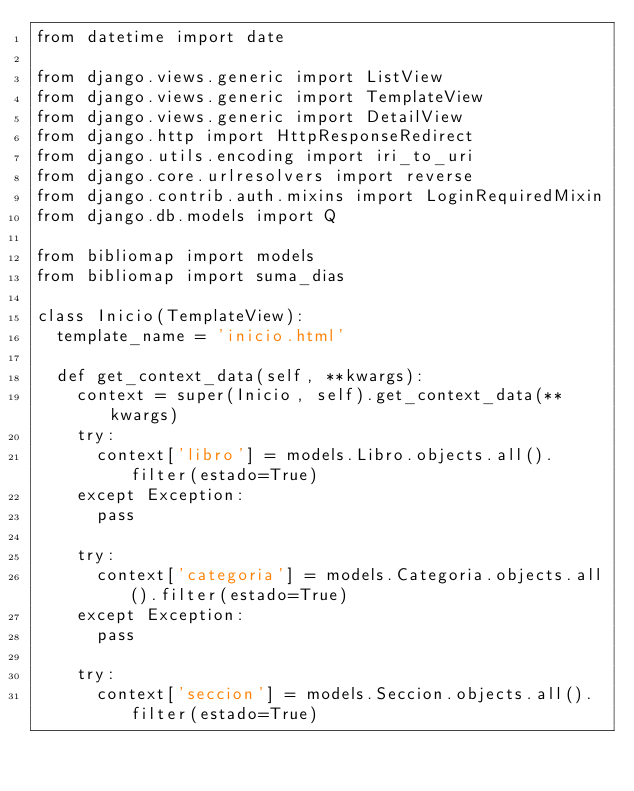Convert code to text. <code><loc_0><loc_0><loc_500><loc_500><_Python_>from datetime import date

from django.views.generic import ListView
from django.views.generic import TemplateView
from django.views.generic import DetailView
from django.http import HttpResponseRedirect
from django.utils.encoding import iri_to_uri
from django.core.urlresolvers import reverse
from django.contrib.auth.mixins import LoginRequiredMixin
from django.db.models import Q

from bibliomap import models
from bibliomap import suma_dias

class Inicio(TemplateView):
	template_name = 'inicio.html'

	def get_context_data(self, **kwargs):
		context = super(Inicio, self).get_context_data(**kwargs)
		try:
			context['libro'] = models.Libro.objects.all().filter(estado=True)
		except Exception:
			pass

		try:
			context['categoria'] = models.Categoria.objects.all().filter(estado=True)
		except Exception:
			pass

		try:
			context['seccion'] = models.Seccion.objects.all().filter(estado=True)</code> 